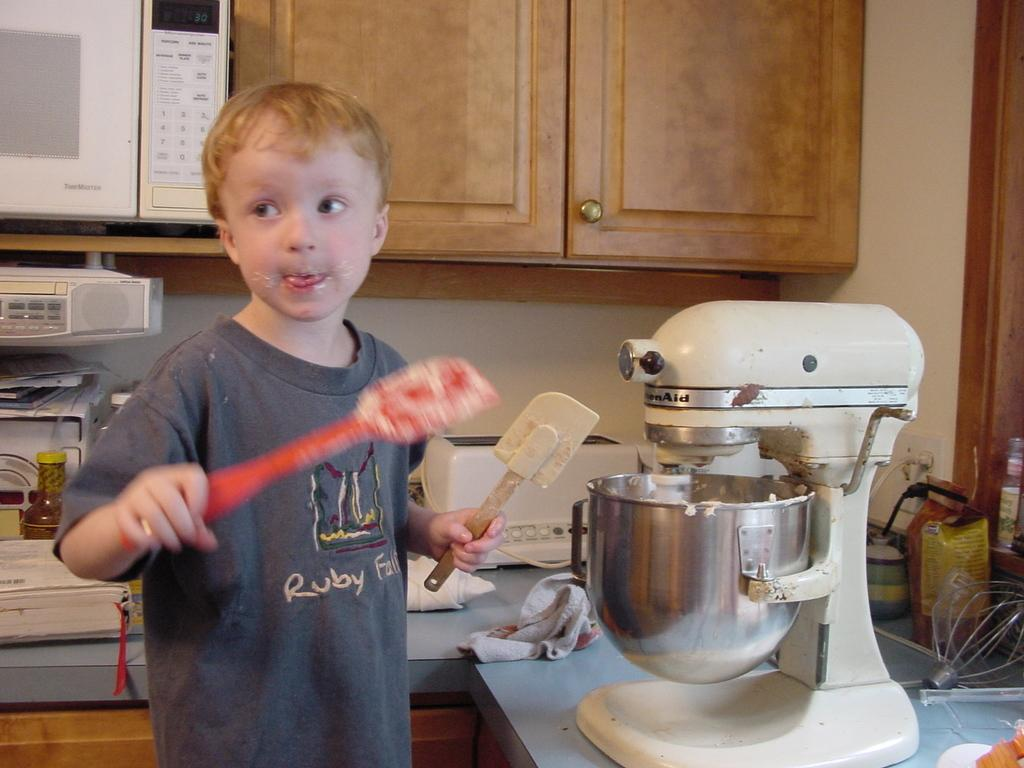<image>
Render a clear and concise summary of the photo. In a kitchen, a young boy interacts with a KitchenAid brand mixer. 